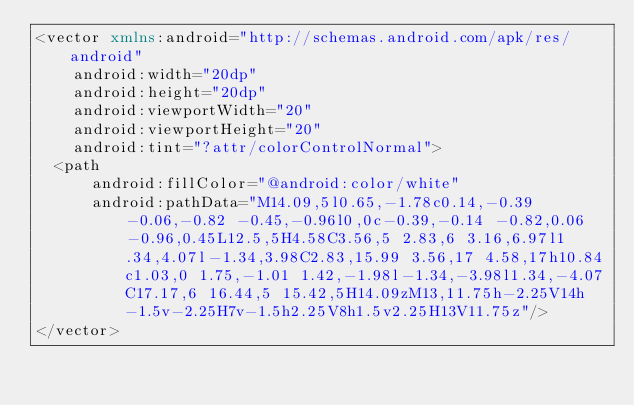Convert code to text. <code><loc_0><loc_0><loc_500><loc_500><_XML_><vector xmlns:android="http://schemas.android.com/apk/res/android"
    android:width="20dp"
    android:height="20dp"
    android:viewportWidth="20"
    android:viewportHeight="20"
    android:tint="?attr/colorControlNormal">
  <path
      android:fillColor="@android:color/white"
      android:pathData="M14.09,5l0.65,-1.78c0.14,-0.39 -0.06,-0.82 -0.45,-0.96l0,0c-0.39,-0.14 -0.82,0.06 -0.96,0.45L12.5,5H4.58C3.56,5 2.83,6 3.16,6.97l1.34,4.07l-1.34,3.98C2.83,15.99 3.56,17 4.58,17h10.84c1.03,0 1.75,-1.01 1.42,-1.98l-1.34,-3.98l1.34,-4.07C17.17,6 16.44,5 15.42,5H14.09zM13,11.75h-2.25V14h-1.5v-2.25H7v-1.5h2.25V8h1.5v2.25H13V11.75z"/>
</vector>
</code> 